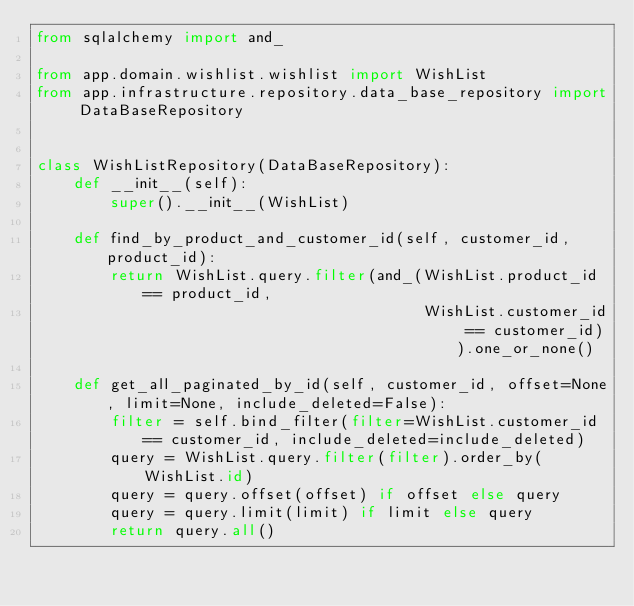Convert code to text. <code><loc_0><loc_0><loc_500><loc_500><_Python_>from sqlalchemy import and_

from app.domain.wishlist.wishlist import WishList
from app.infrastructure.repository.data_base_repository import DataBaseRepository


class WishListRepository(DataBaseRepository):
    def __init__(self):
        super().__init__(WishList)

    def find_by_product_and_customer_id(self, customer_id, product_id):
        return WishList.query.filter(and_(WishList.product_id == product_id,
                                          WishList.customer_id == customer_id)).one_or_none()

    def get_all_paginated_by_id(self, customer_id, offset=None, limit=None, include_deleted=False):
        filter = self.bind_filter(filter=WishList.customer_id == customer_id, include_deleted=include_deleted)
        query = WishList.query.filter(filter).order_by(WishList.id)
        query = query.offset(offset) if offset else query
        query = query.limit(limit) if limit else query
        return query.all()
</code> 